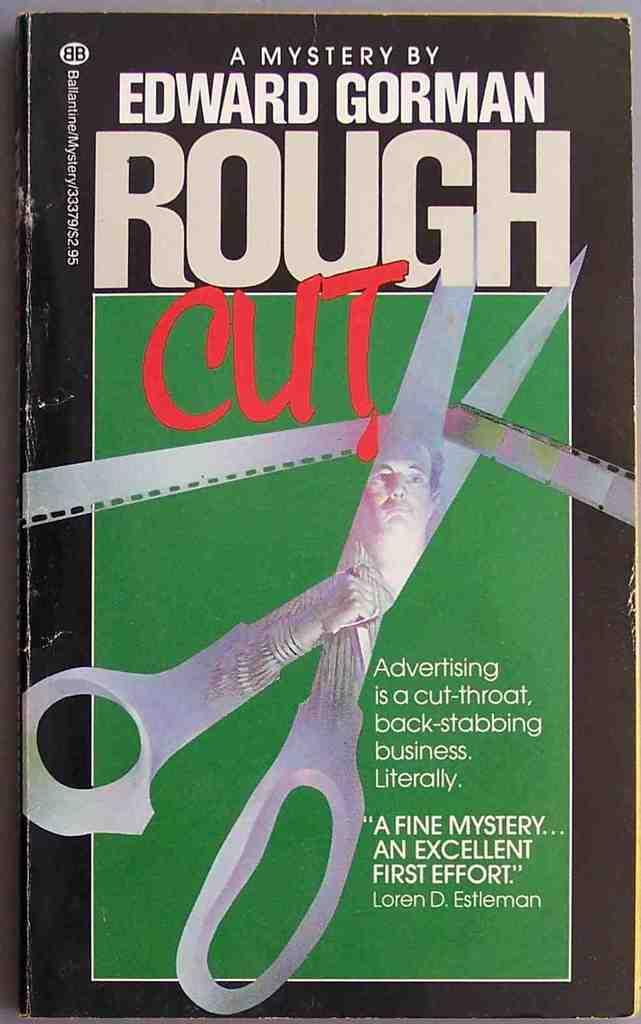<image>
Summarize the visual content of the image. The mystery book "Rough Cut" by Edward Gorman. 